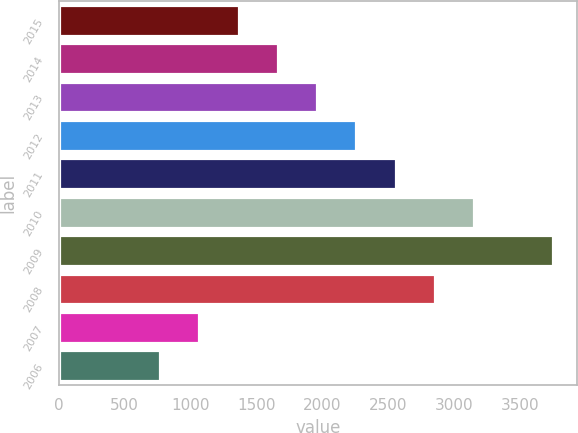Convert chart to OTSL. <chart><loc_0><loc_0><loc_500><loc_500><bar_chart><fcel>2015<fcel>2014<fcel>2013<fcel>2012<fcel>2011<fcel>2010<fcel>2009<fcel>2008<fcel>2007<fcel>2006<nl><fcel>1366.6<fcel>1664.4<fcel>1962.2<fcel>2260<fcel>2557.8<fcel>3153.4<fcel>3749<fcel>2855.6<fcel>1068.8<fcel>771<nl></chart> 